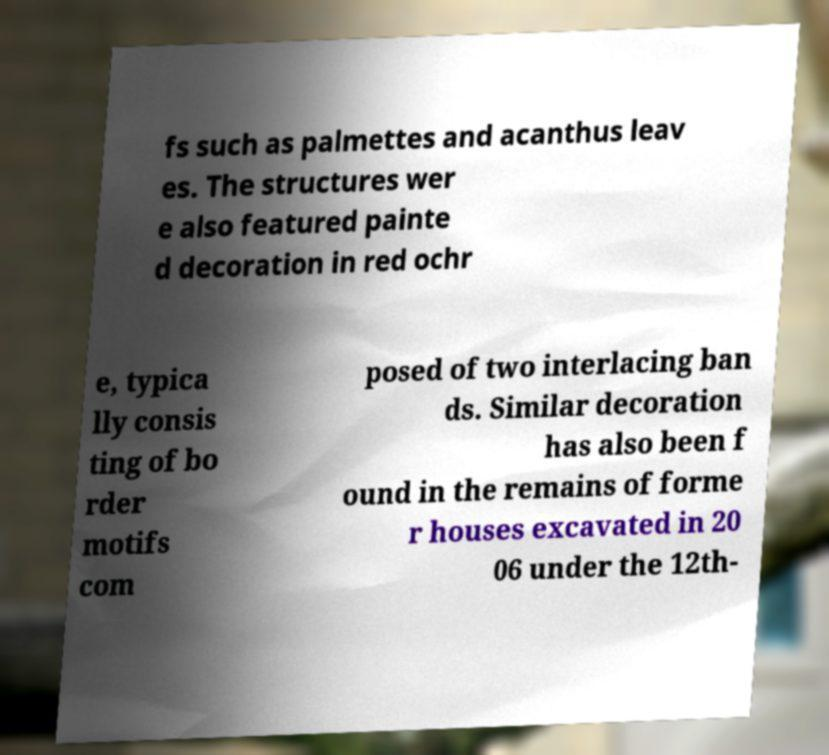Could you extract and type out the text from this image? fs such as palmettes and acanthus leav es. The structures wer e also featured painte d decoration in red ochr e, typica lly consis ting of bo rder motifs com posed of two interlacing ban ds. Similar decoration has also been f ound in the remains of forme r houses excavated in 20 06 under the 12th- 